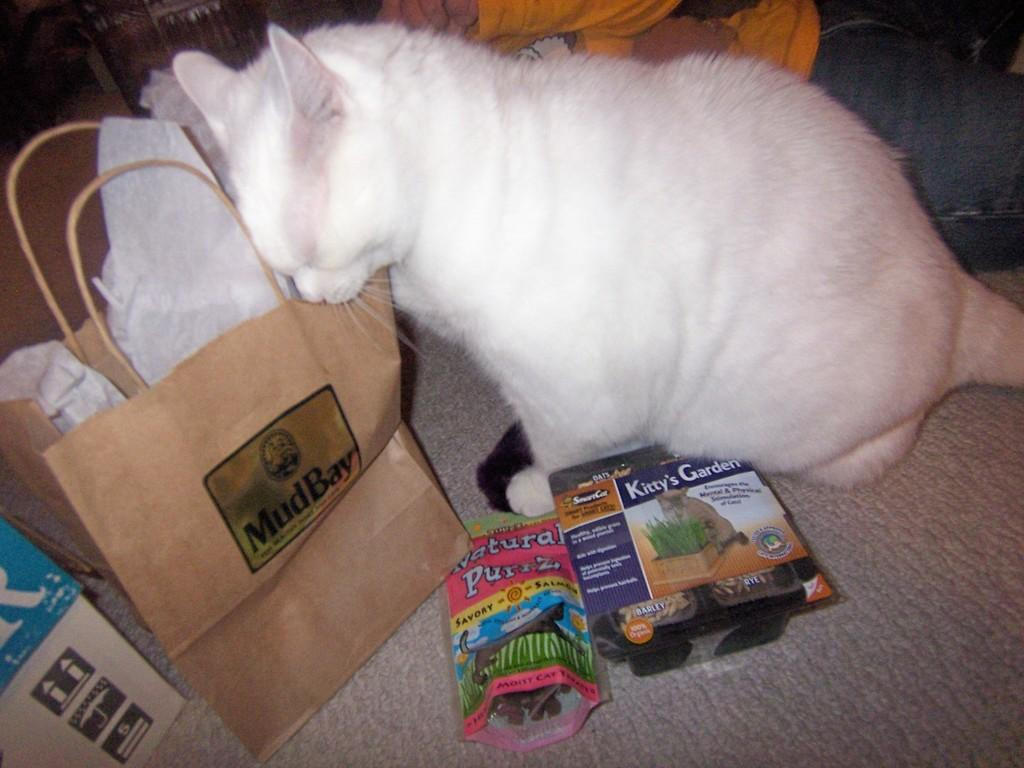What type of animal is in the image? There is a cat in the image. What color is the cat? The cat is white in color. What is the cat sitting on in the image? There is a carpet in the image. What other object can be seen in the image? There is a paper bag in the image. Can you describe the person in the image? There is a person wearing clothes in the image. What type of apparatus is being used to paste the cat in the image? There is no apparatus or pasting activity present in the image; it is a photograph of a cat sitting on a carpet. 